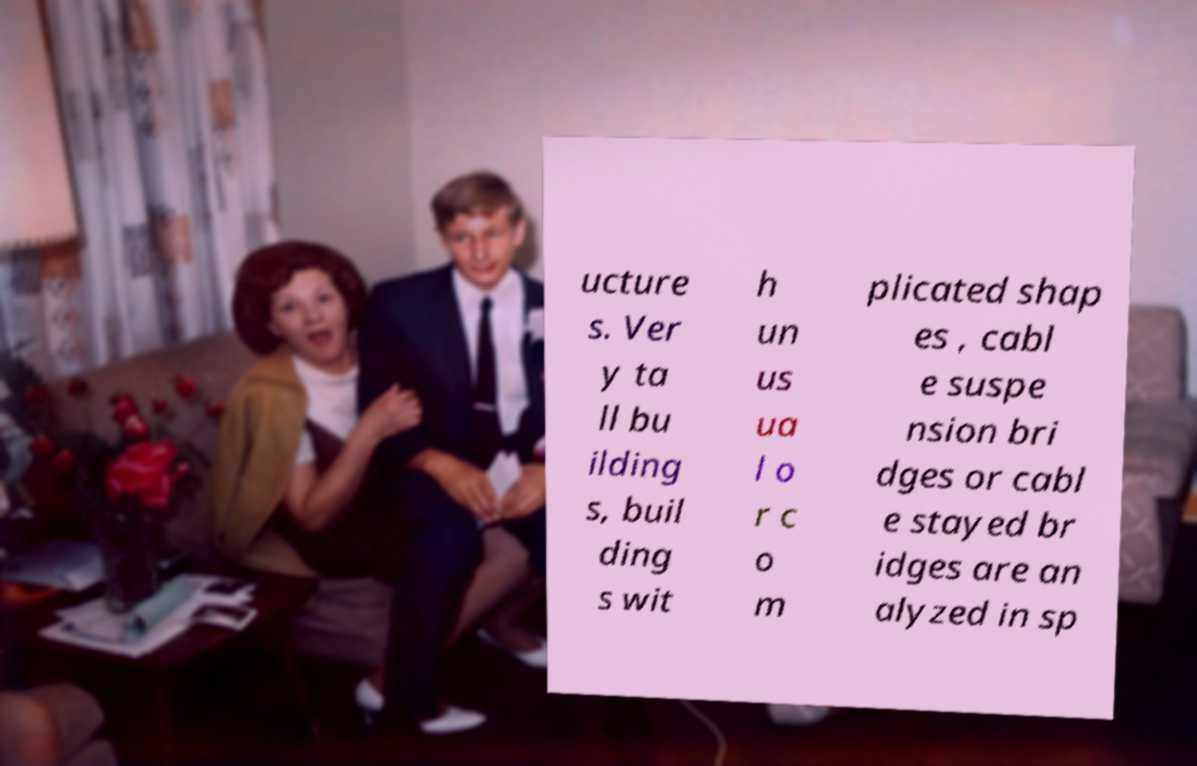Can you accurately transcribe the text from the provided image for me? ucture s. Ver y ta ll bu ilding s, buil ding s wit h un us ua l o r c o m plicated shap es , cabl e suspe nsion bri dges or cabl e stayed br idges are an alyzed in sp 